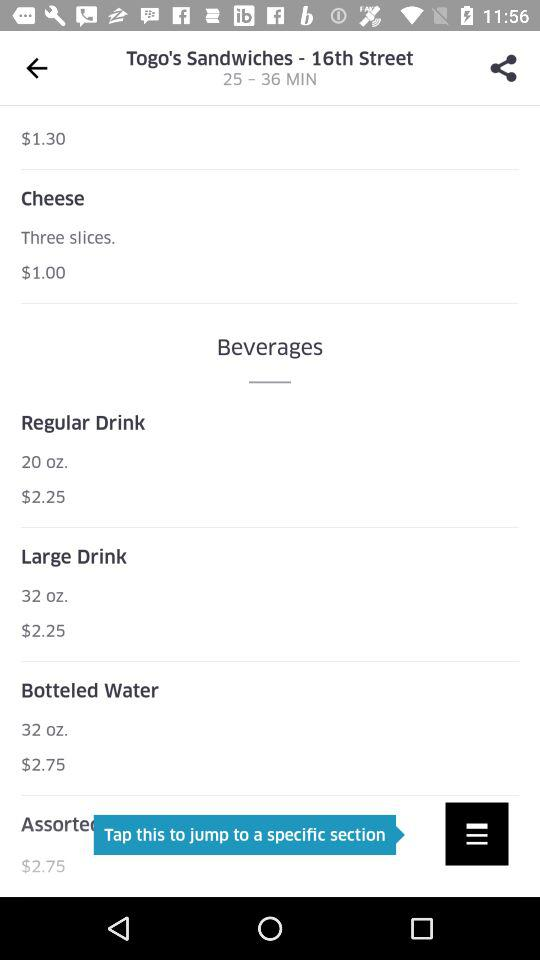What's the quantity of the regular drink? The quantity of the regular drink is 20 oz. 